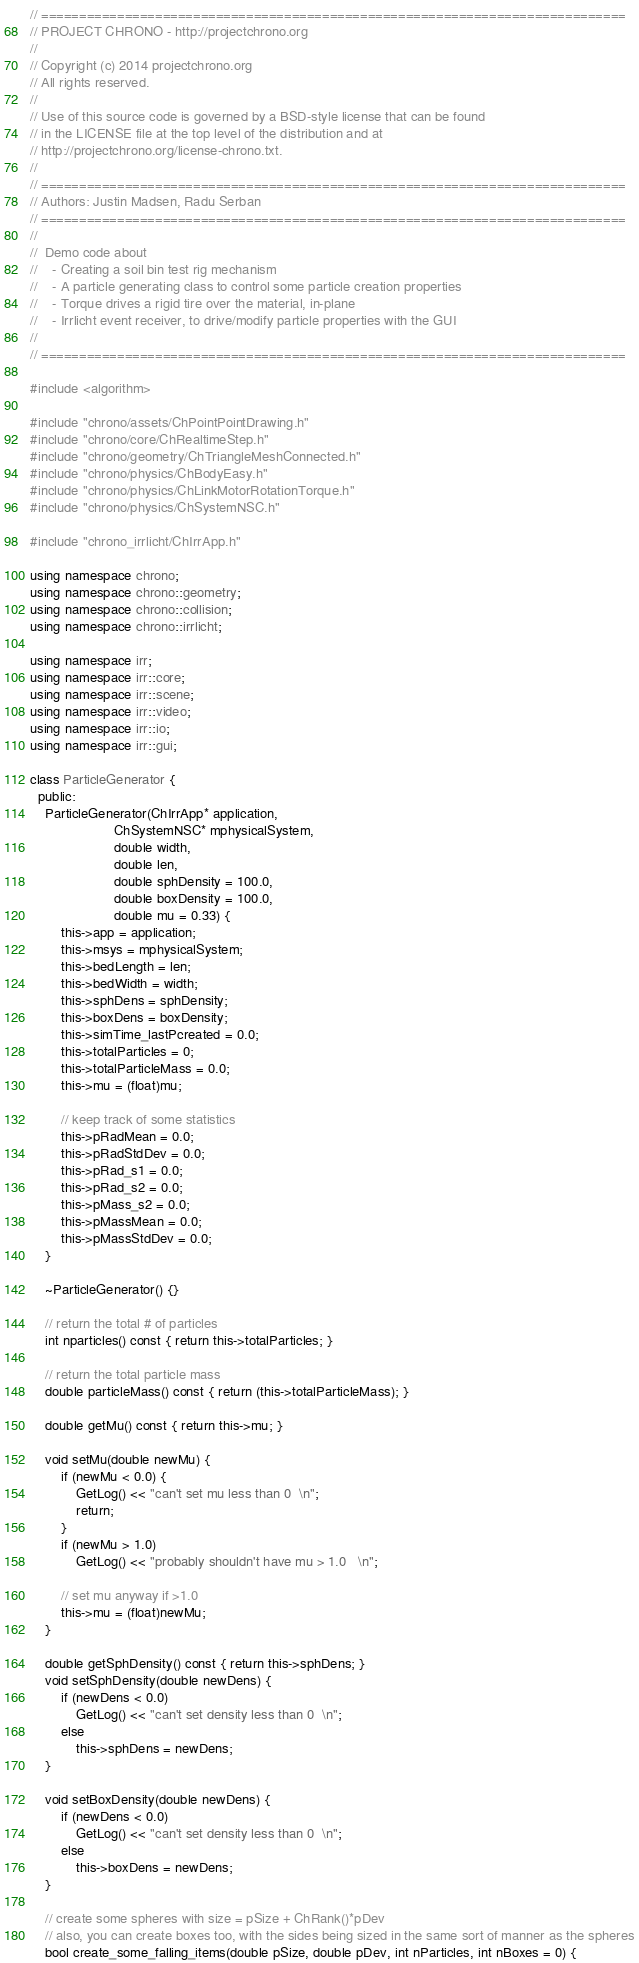Convert code to text. <code><loc_0><loc_0><loc_500><loc_500><_C++_>// =============================================================================
// PROJECT CHRONO - http://projectchrono.org
//
// Copyright (c) 2014 projectchrono.org
// All rights reserved.
//
// Use of this source code is governed by a BSD-style license that can be found
// in the LICENSE file at the top level of the distribution and at
// http://projectchrono.org/license-chrono.txt.
//
// =============================================================================
// Authors: Justin Madsen, Radu Serban
// =============================================================================
//
//  Demo code about
//    - Creating a soil bin test rig mechanism
//    - A particle generating class to control some particle creation properties
//	  - Torque drives a rigid tire over the material, in-plane
//    - Irrlicht event receiver, to drive/modify particle properties with the GUI
//
// =============================================================================

#include <algorithm>

#include "chrono/assets/ChPointPointDrawing.h"
#include "chrono/core/ChRealtimeStep.h"
#include "chrono/geometry/ChTriangleMeshConnected.h"
#include "chrono/physics/ChBodyEasy.h"
#include "chrono/physics/ChLinkMotorRotationTorque.h"
#include "chrono/physics/ChSystemNSC.h"

#include "chrono_irrlicht/ChIrrApp.h"

using namespace chrono;
using namespace chrono::geometry;
using namespace chrono::collision;
using namespace chrono::irrlicht;

using namespace irr;
using namespace irr::core;
using namespace irr::scene;
using namespace irr::video;
using namespace irr::io;
using namespace irr::gui;

class ParticleGenerator {
  public:
    ParticleGenerator(ChIrrApp* application,
                      ChSystemNSC* mphysicalSystem,
                      double width,
                      double len,
                      double sphDensity = 100.0,
                      double boxDensity = 100.0,
                      double mu = 0.33) {
        this->app = application;
        this->msys = mphysicalSystem;
        this->bedLength = len;
        this->bedWidth = width;
        this->sphDens = sphDensity;
        this->boxDens = boxDensity;
        this->simTime_lastPcreated = 0.0;
        this->totalParticles = 0;
        this->totalParticleMass = 0.0;
        this->mu = (float)mu;

        // keep track of some statistics
        this->pRadMean = 0.0;
        this->pRadStdDev = 0.0;
        this->pRad_s1 = 0.0;
        this->pRad_s2 = 0.0;
        this->pMass_s2 = 0.0;
        this->pMassMean = 0.0;
        this->pMassStdDev = 0.0;
    }

    ~ParticleGenerator() {}

    // return the total # of particles
    int nparticles() const { return this->totalParticles; }

    // return the total particle mass
    double particleMass() const { return (this->totalParticleMass); }

    double getMu() const { return this->mu; }

    void setMu(double newMu) {
        if (newMu < 0.0) {
            GetLog() << "can't set mu less than 0  \n";
            return;
        }
        if (newMu > 1.0)
            GetLog() << "probably shouldn't have mu > 1.0   \n";

        // set mu anyway if >1.0
        this->mu = (float)newMu;
    }

    double getSphDensity() const { return this->sphDens; }
    void setSphDensity(double newDens) {
        if (newDens < 0.0)
            GetLog() << "can't set density less than 0  \n";
        else
            this->sphDens = newDens;
    }

    void setBoxDensity(double newDens) {
        if (newDens < 0.0)
            GetLog() << "can't set density less than 0  \n";
        else
            this->boxDens = newDens;
    }

    // create some spheres with size = pSize + ChRank()*pDev
    // also, you can create boxes too, with the sides being sized in the same sort of manner as the spheres
    bool create_some_falling_items(double pSize, double pDev, int nParticles, int nBoxes = 0) {</code> 